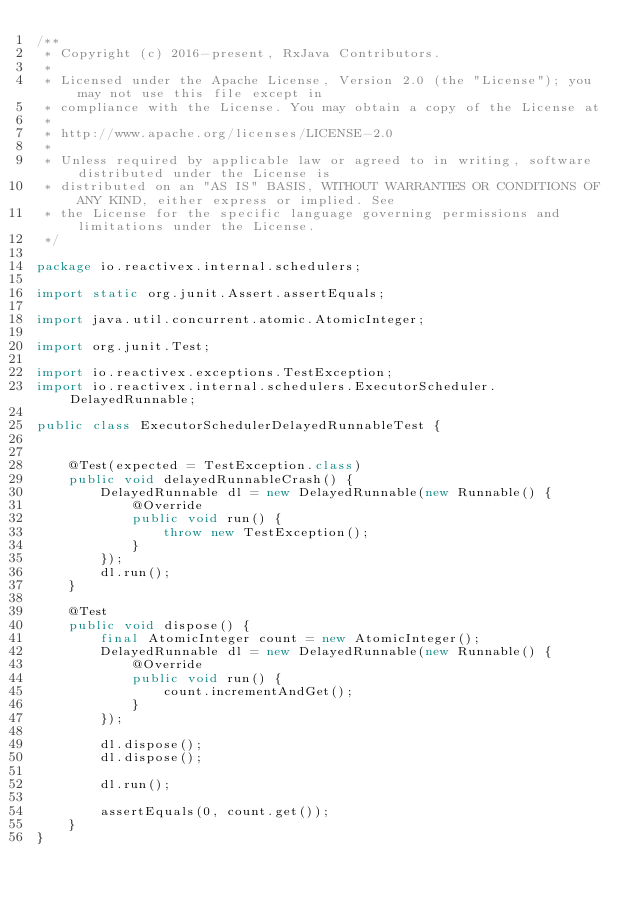<code> <loc_0><loc_0><loc_500><loc_500><_Java_>/**
 * Copyright (c) 2016-present, RxJava Contributors.
 *
 * Licensed under the Apache License, Version 2.0 (the "License"); you may not use this file except in
 * compliance with the License. You may obtain a copy of the License at
 *
 * http://www.apache.org/licenses/LICENSE-2.0
 *
 * Unless required by applicable law or agreed to in writing, software distributed under the License is
 * distributed on an "AS IS" BASIS, WITHOUT WARRANTIES OR CONDITIONS OF ANY KIND, either express or implied. See
 * the License for the specific language governing permissions and limitations under the License.
 */

package io.reactivex.internal.schedulers;

import static org.junit.Assert.assertEquals;

import java.util.concurrent.atomic.AtomicInteger;

import org.junit.Test;

import io.reactivex.exceptions.TestException;
import io.reactivex.internal.schedulers.ExecutorScheduler.DelayedRunnable;

public class ExecutorSchedulerDelayedRunnableTest {


    @Test(expected = TestException.class)
    public void delayedRunnableCrash() {
        DelayedRunnable dl = new DelayedRunnable(new Runnable() {
            @Override
            public void run() {
                throw new TestException();
            }
        });
        dl.run();
    }

    @Test
    public void dispose() {
        final AtomicInteger count = new AtomicInteger();
        DelayedRunnable dl = new DelayedRunnable(new Runnable() {
            @Override
            public void run() {
                count.incrementAndGet();
            }
        });

        dl.dispose();
        dl.dispose();

        dl.run();

        assertEquals(0, count.get());
    }
}
</code> 